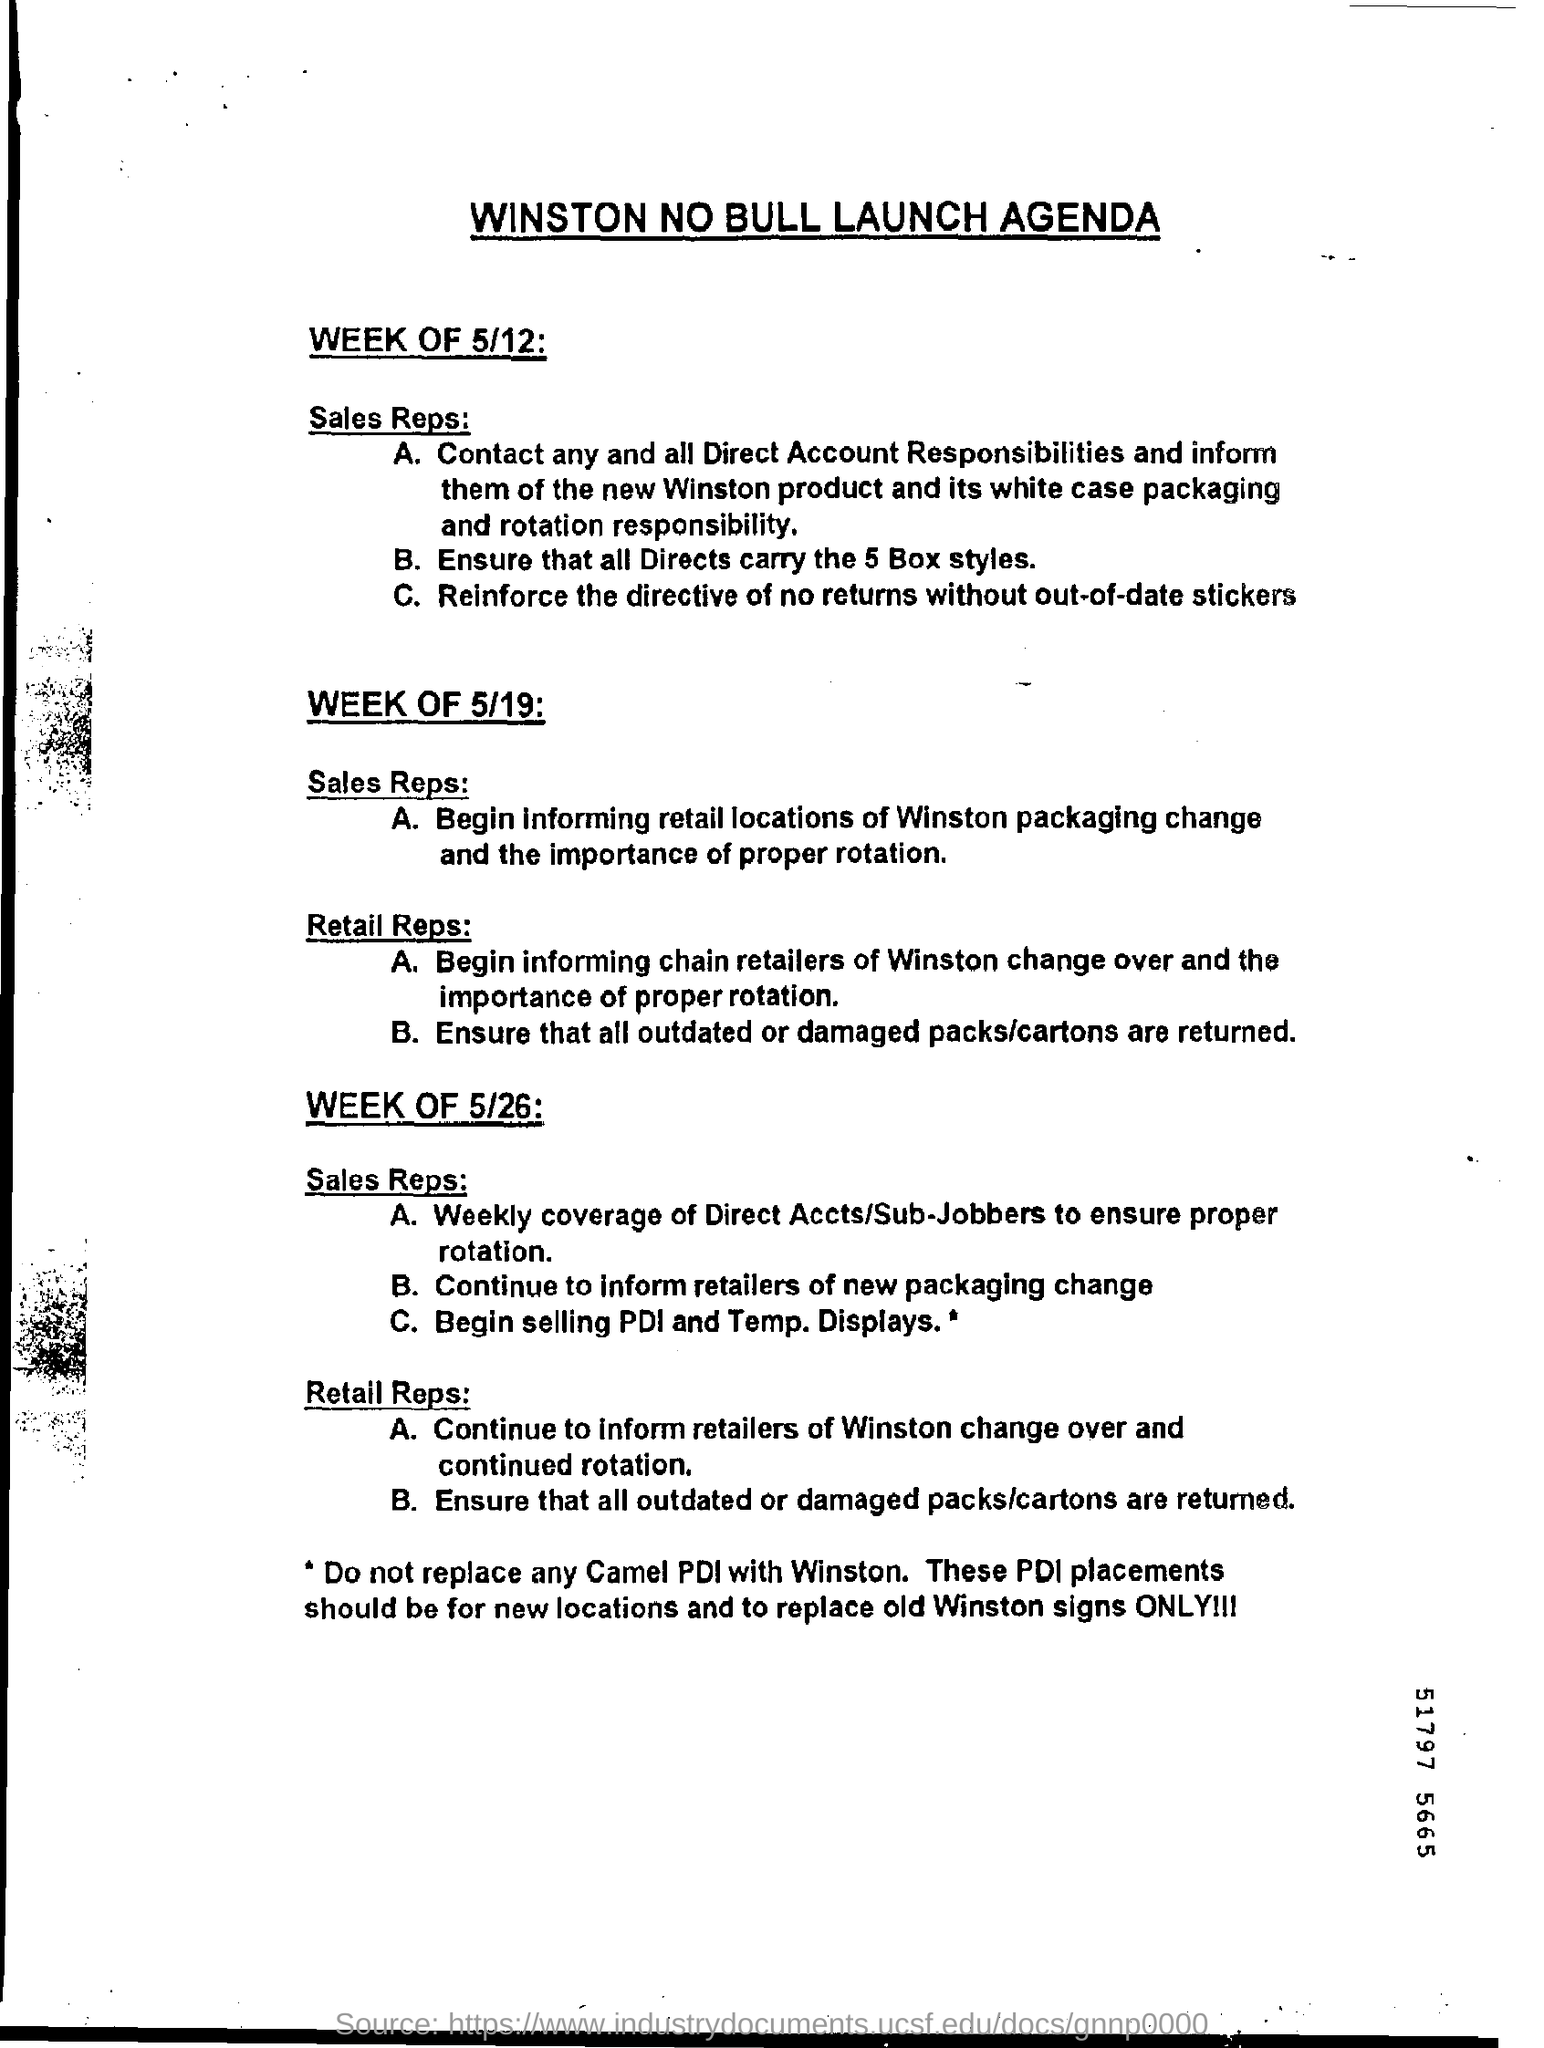Outline some significant characteristics in this image. The heading of the page is 'What is the launch agenda for Winston no bull?'. It is necessary to ensure that all directs are carrying a minimum of 5 box styles. 